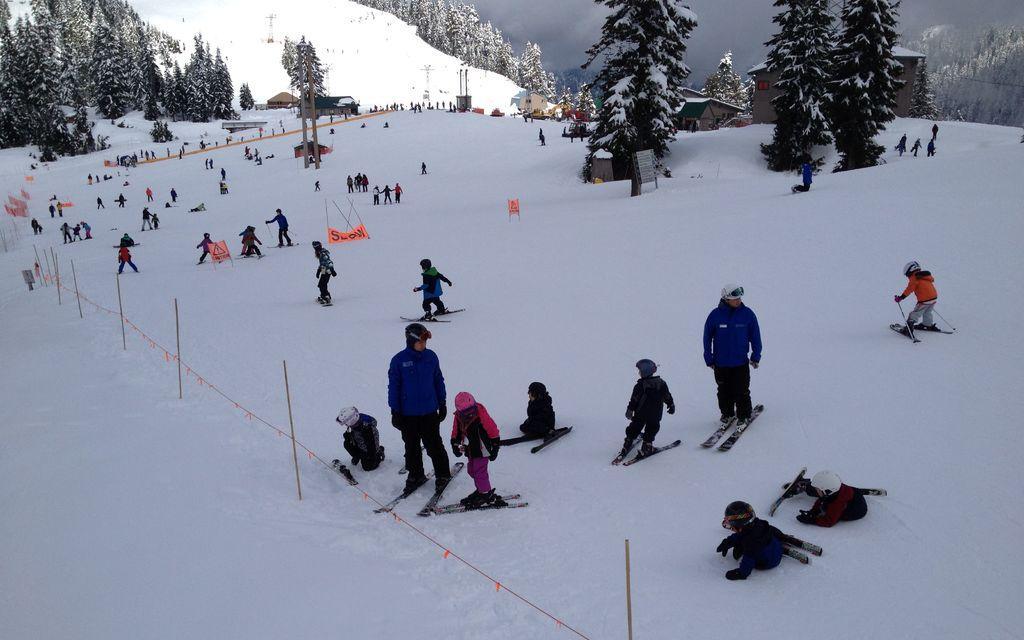Please provide a concise description of this image. In this image there are few people skating on the surface of the snow. In the background there are houses and trees. 